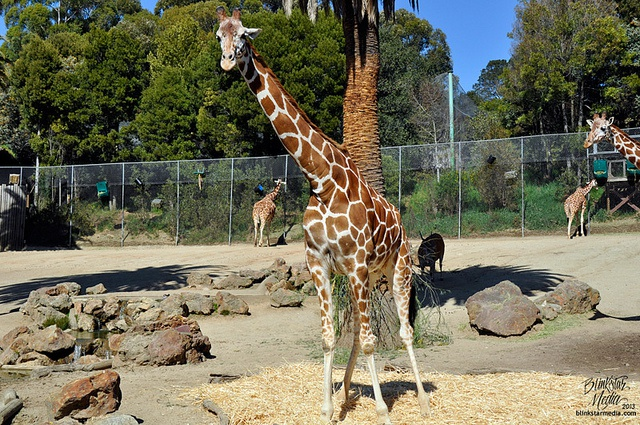Describe the objects in this image and their specific colors. I can see giraffe in purple, brown, ivory, maroon, and gray tones, giraffe in purple, lightgray, black, maroon, and darkgray tones, giraffe in purple, lightgray, black, maroon, and darkgray tones, giraffe in purple, black, tan, and gray tones, and giraffe in purple, tan, olive, and gray tones in this image. 